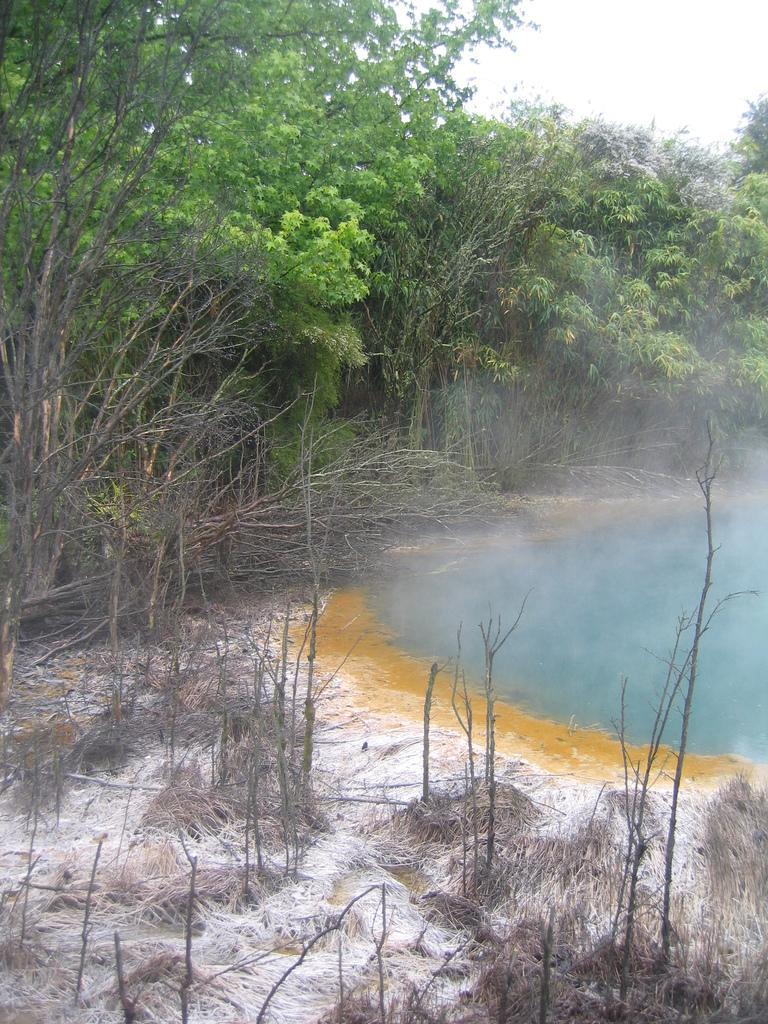Describe this image in one or two sentences. In this image at the bottom there is grass, and there is some white powder and in the background there is a pond, trees, grass and some fog is coming out. At the top there is sky. 